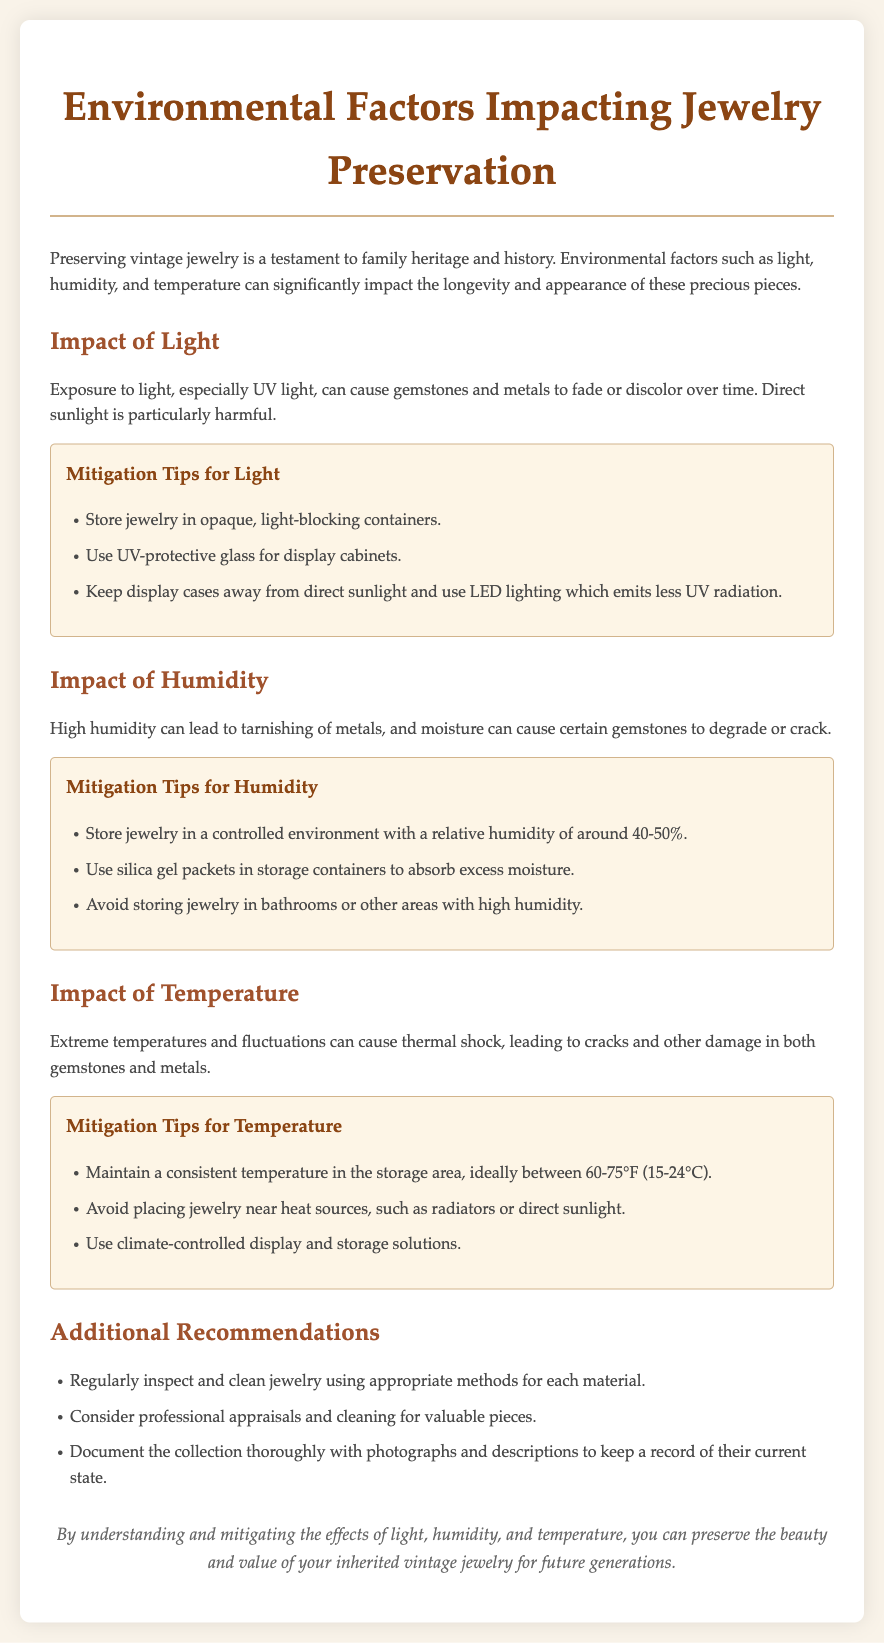What are the main environmental factors affecting jewelry preservation? The document lists light, humidity, and temperature as the main environmental factors impacting jewelry preservation.
Answer: light, humidity, and temperature What is the ideal relative humidity for storing jewelry? The document states that jewelry should be stored in a controlled environment with a relative humidity of around 40-50%.
Answer: 40-50% What should be used in storage containers to absorb excess moisture? The document recommends using silica gel packets in storage containers to help absorb excess moisture.
Answer: silica gel packets What is the recommended temperature range for storing jewelry? The document advises maintaining a consistent temperature between 60-75°F (15-24°C) in the storage area for jewelry.
Answer: 60-75°F Which type of lighting should be avoided for display cases? The document mentions that display cases should avoid direct sunlight and suggests using LED lighting, which emits less UV radiation.
Answer: direct sunlight What can be done to mitigate light exposure? The document suggests storing jewelry in opaque, light-blocking containers to mitigate light exposure.
Answer: opaque, light-blocking containers What is a potential consequence of extreme temperature fluctuations? The document indicates that extreme temperatures and fluctuations can cause thermal shock, leading to cracks and other damage.
Answer: thermal shock Which area should be avoided for storing jewelry? The document advises avoiding storage in bathrooms or other areas with high humidity for jewelry.
Answer: bathrooms What should be done to regularly maintain jewelry? The document advises regularly inspecting and cleaning jewelry using appropriate methods for each material.
Answer: inspect and clean 